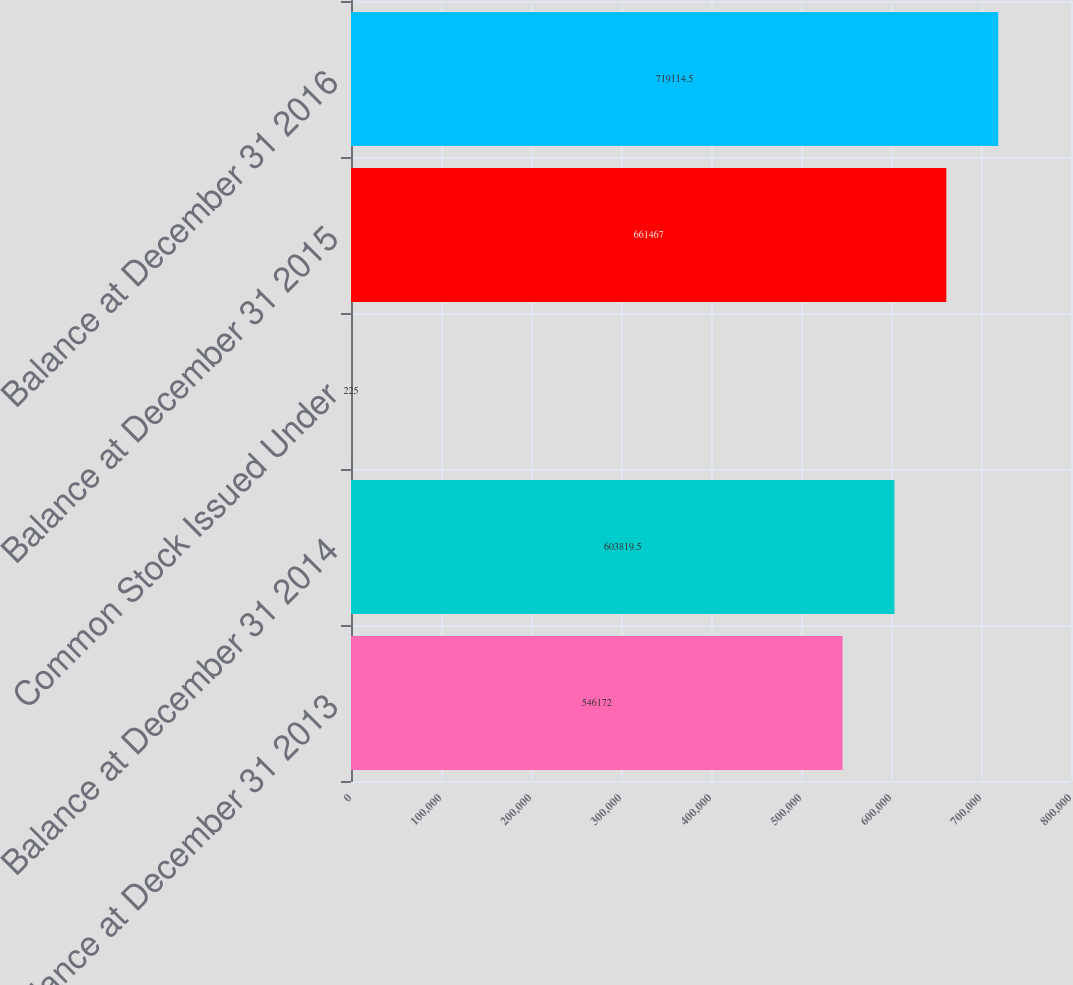Convert chart to OTSL. <chart><loc_0><loc_0><loc_500><loc_500><bar_chart><fcel>Balance at December 31 2013<fcel>Balance at December 31 2014<fcel>Common Stock Issued Under<fcel>Balance at December 31 2015<fcel>Balance at December 31 2016<nl><fcel>546172<fcel>603820<fcel>225<fcel>661467<fcel>719114<nl></chart> 